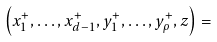<formula> <loc_0><loc_0><loc_500><loc_500>\left ( x ^ { + } _ { 1 } , \dots , x ^ { + } _ { d - 1 } , y ^ { + } _ { 1 } , \dots , y ^ { + } _ { \rho } , z \right ) =</formula> 